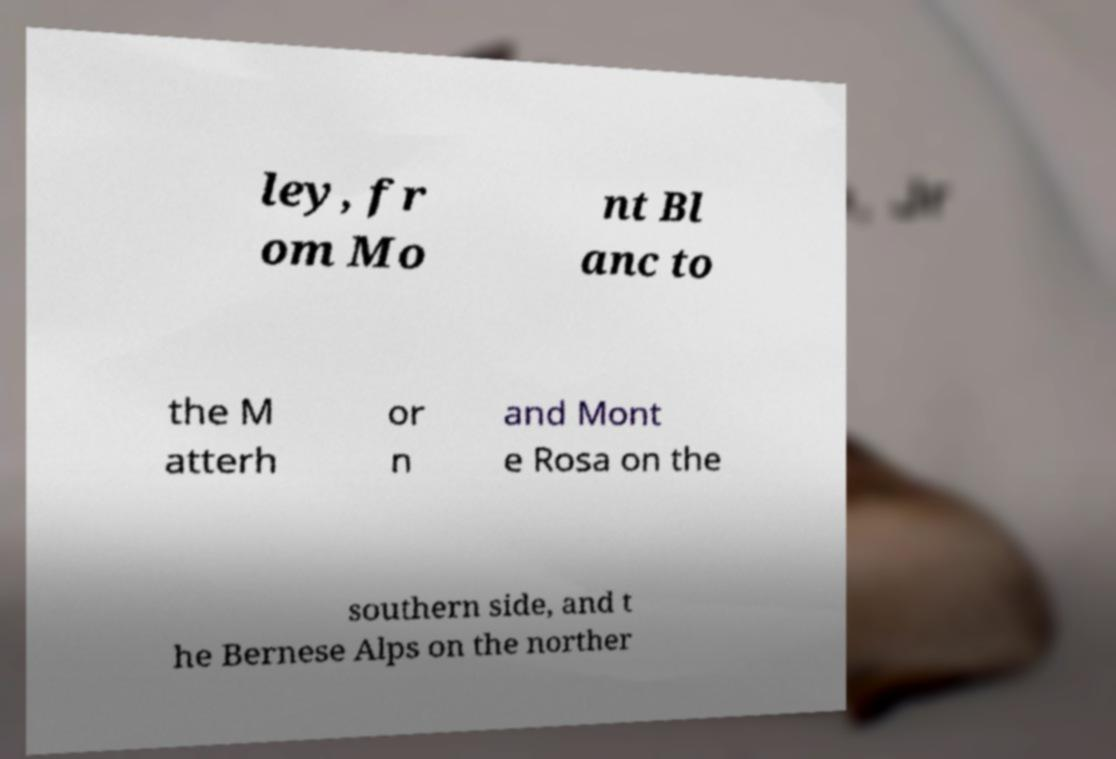Could you assist in decoding the text presented in this image and type it out clearly? ley, fr om Mo nt Bl anc to the M atterh or n and Mont e Rosa on the southern side, and t he Bernese Alps on the norther 